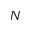Convert formula to latex. <formula><loc_0><loc_0><loc_500><loc_500>N</formula> 